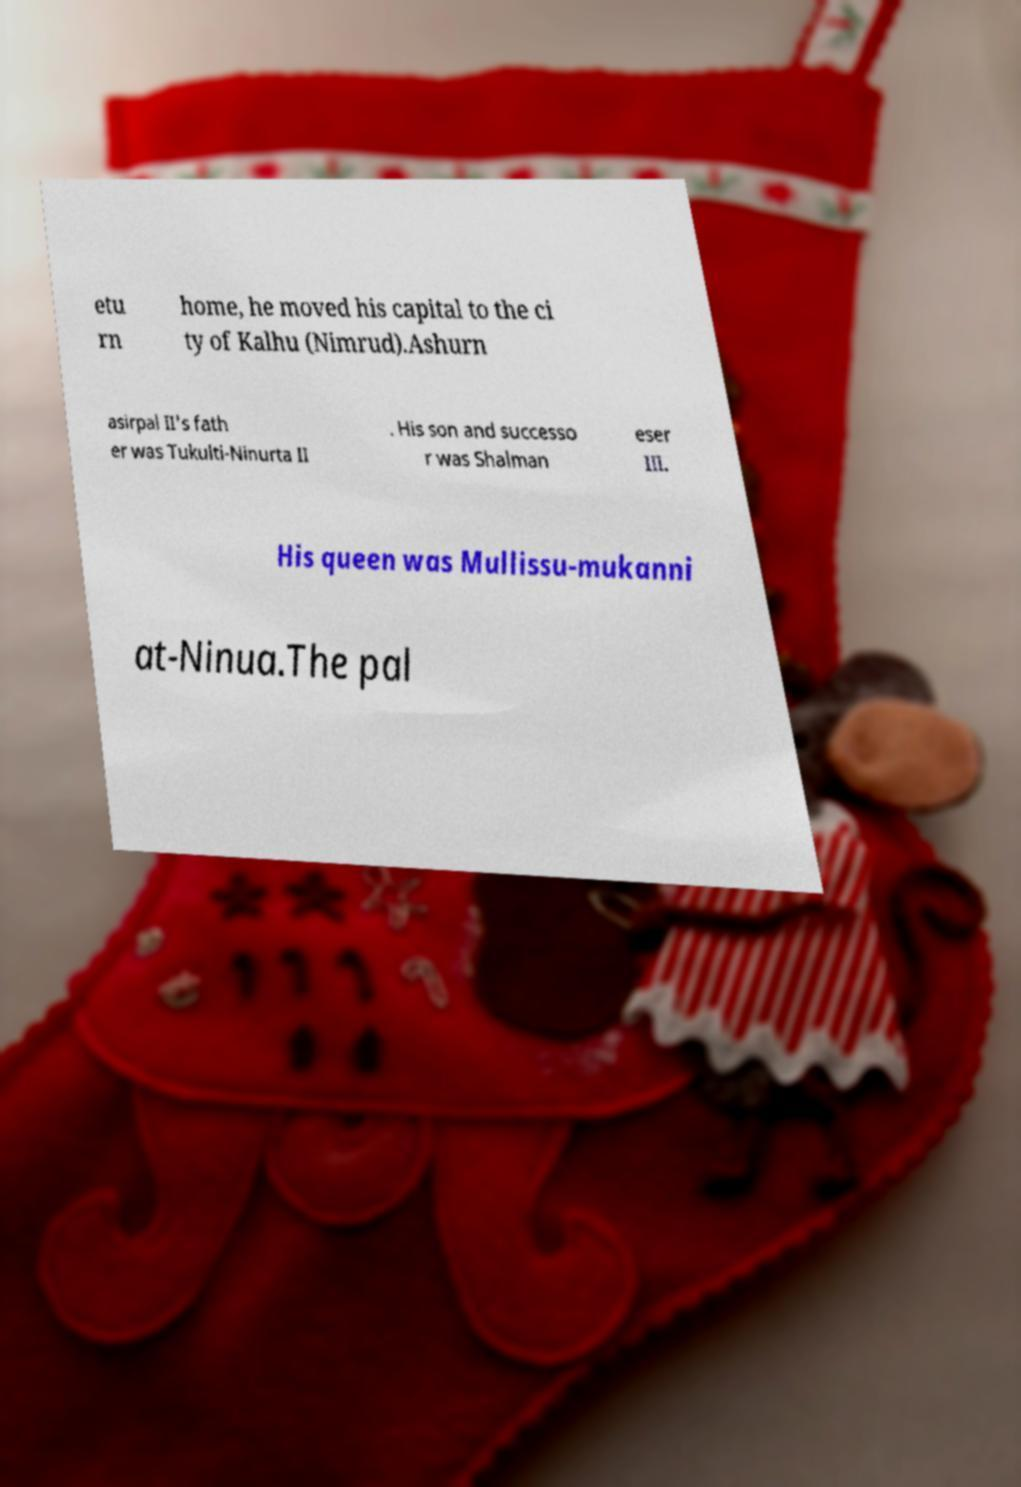I need the written content from this picture converted into text. Can you do that? etu rn home, he moved his capital to the ci ty of Kalhu (Nimrud).Ashurn asirpal II's fath er was Tukulti-Ninurta II . His son and successo r was Shalman eser III. His queen was Mullissu-mukanni at-Ninua.The pal 